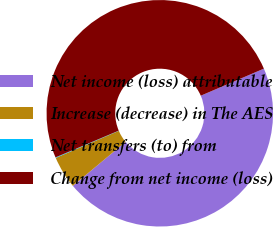<chart> <loc_0><loc_0><loc_500><loc_500><pie_chart><fcel>Net income (loss) attributable<fcel>Increase (decrease) in The AES<fcel>Net transfers (to) from<fcel>Change from net income (loss)<nl><fcel>45.38%<fcel>4.62%<fcel>0.08%<fcel>49.92%<nl></chart> 